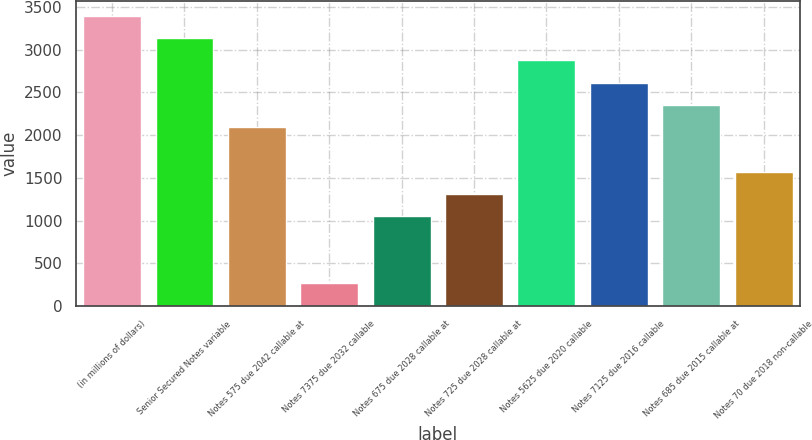<chart> <loc_0><loc_0><loc_500><loc_500><bar_chart><fcel>(in millions of dollars)<fcel>Senior Secured Notes variable<fcel>Notes 575 due 2042 callable at<fcel>Notes 7375 due 2032 callable<fcel>Notes 675 due 2028 callable at<fcel>Notes 725 due 2028 callable at<fcel>Notes 5625 due 2020 callable<fcel>Notes 7125 due 2016 callable<fcel>Notes 685 due 2015 callable at<fcel>Notes 70 due 2018 non-callable<nl><fcel>3393.89<fcel>3133.26<fcel>2090.74<fcel>266.33<fcel>1048.22<fcel>1308.85<fcel>2872.63<fcel>2612<fcel>2351.37<fcel>1569.48<nl></chart> 